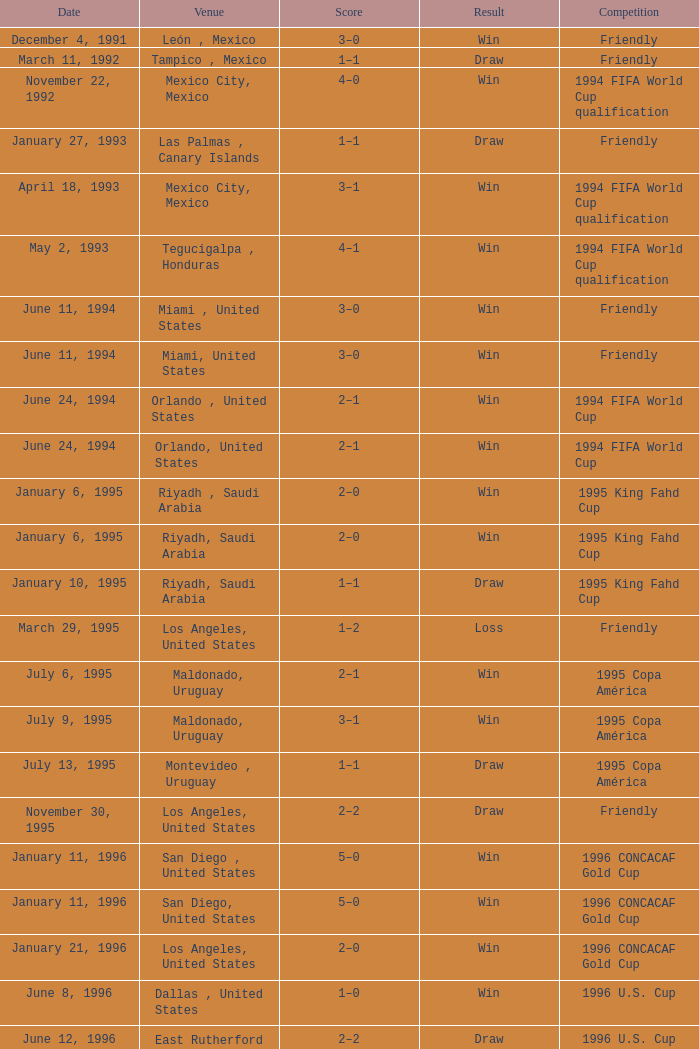What is Result, when Date is "June 11, 1994", and when Venue is "Miami, United States"? Win, Win. 